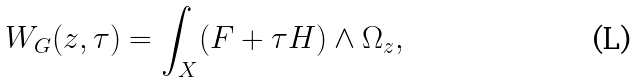<formula> <loc_0><loc_0><loc_500><loc_500>W _ { G } ( z , \tau ) = \int _ { X } ( F + \tau H ) \wedge \Omega _ { z } ,</formula> 